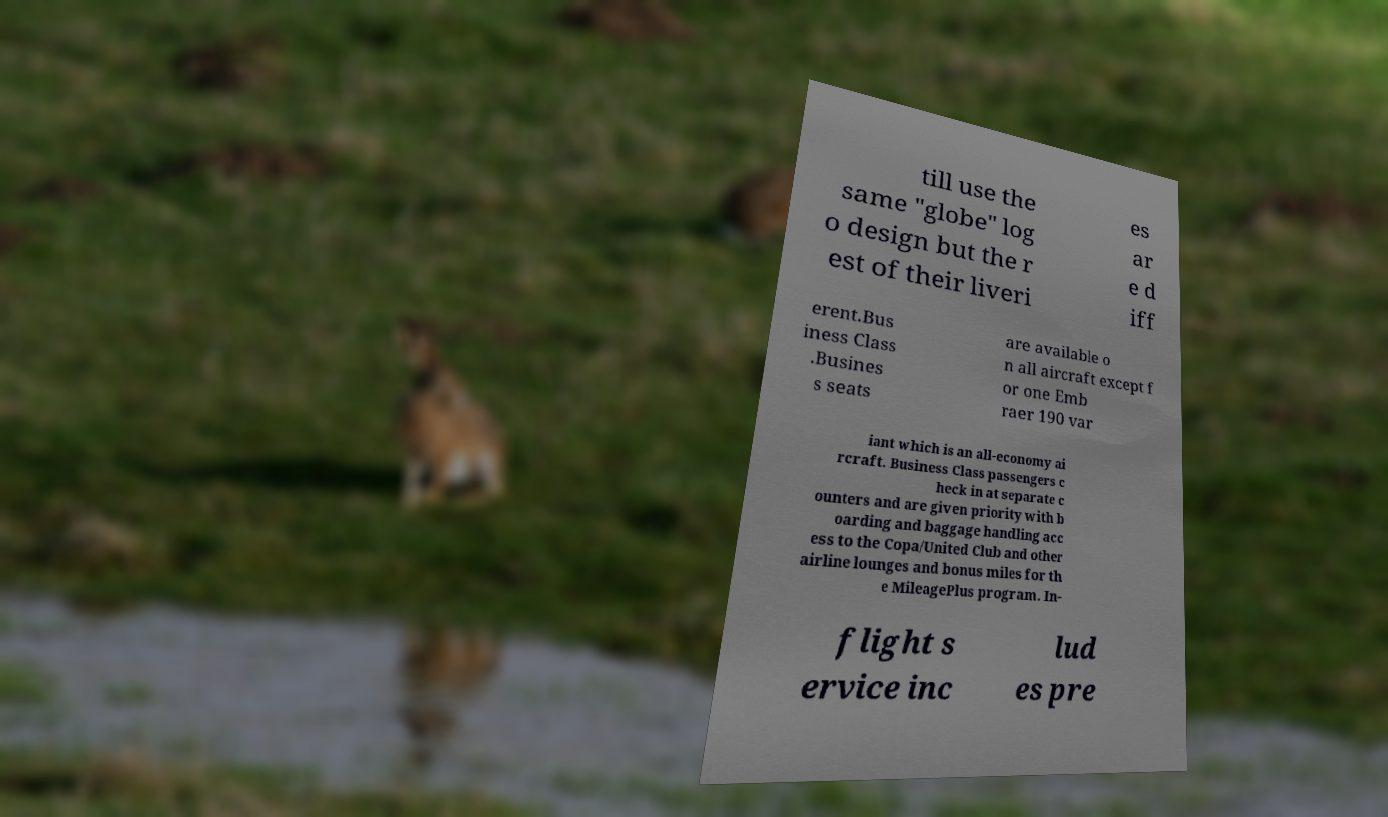Could you assist in decoding the text presented in this image and type it out clearly? till use the same "globe" log o design but the r est of their liveri es ar e d iff erent.Bus iness Class .Busines s seats are available o n all aircraft except f or one Emb raer 190 var iant which is an all-economy ai rcraft. Business Class passengers c heck in at separate c ounters and are given priority with b oarding and baggage handling acc ess to the Copa/United Club and other airline lounges and bonus miles for th e MileagePlus program. In- flight s ervice inc lud es pre 